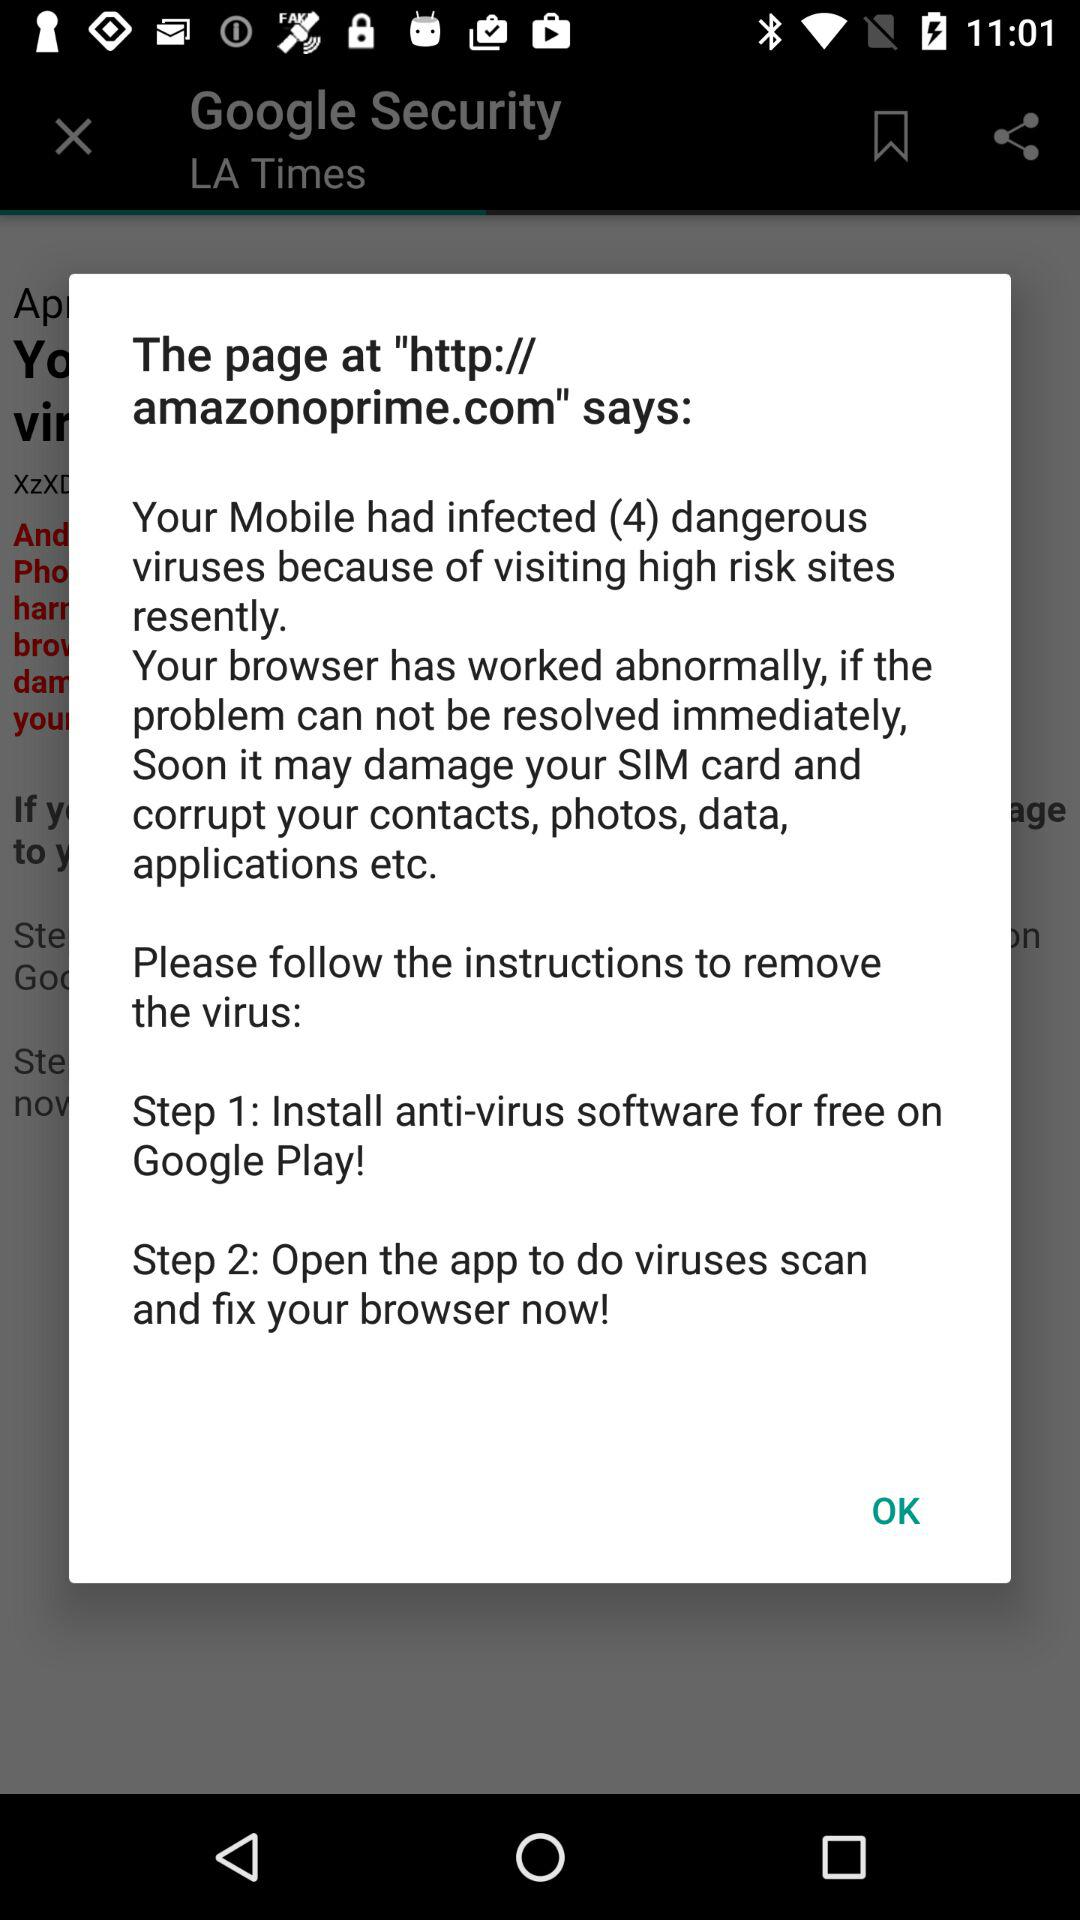How many steps are there to remove the virus?
Answer the question using a single word or phrase. 2 